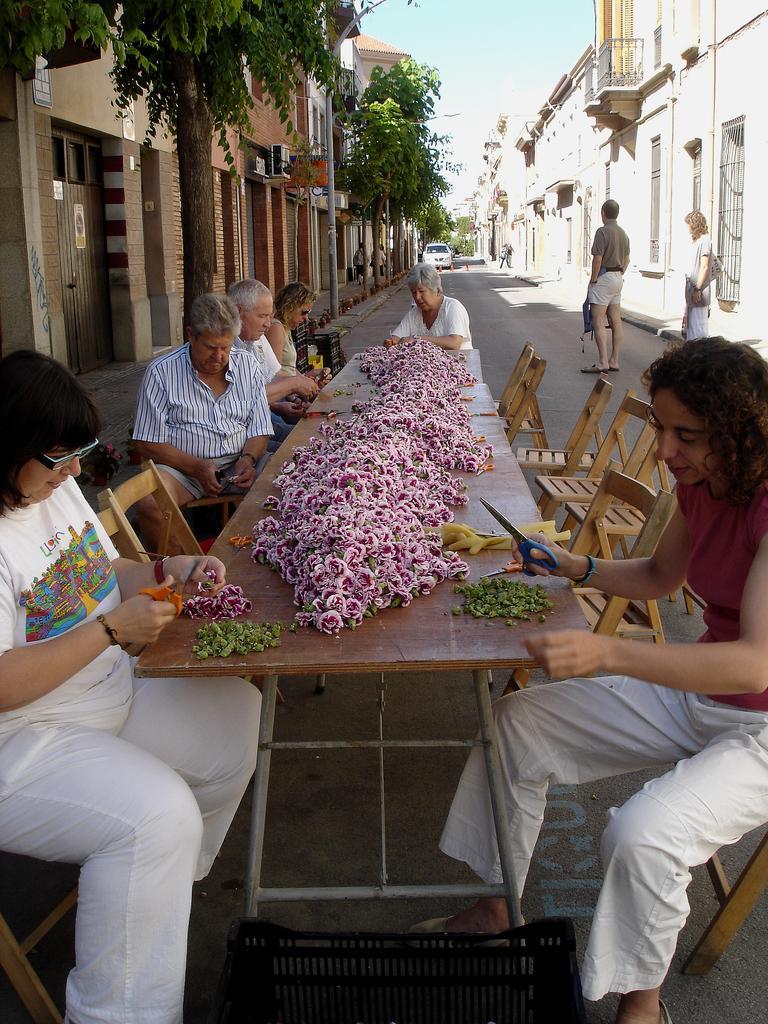How would you summarize this image in a sentence or two? in the picture we can see the street in which people are sitting on the chair with the table in front of them,they are cutting some material by having scissors in their hand,here we can also see some trees and we can also see some buildings which are near to the trees,here we can also see the clear sky,there was car in the street 